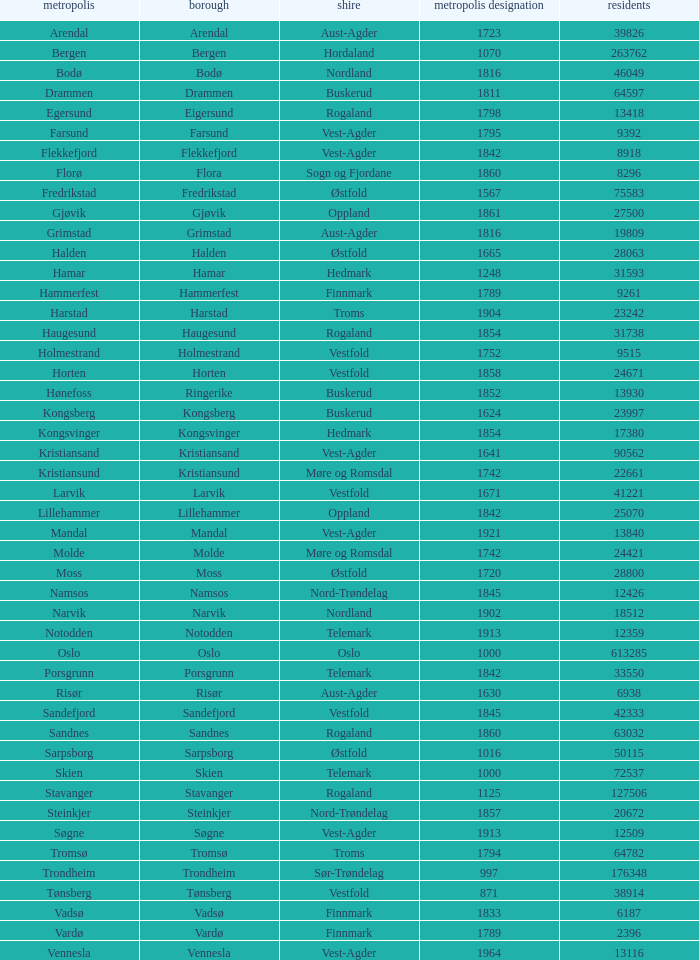What is the total population in the city/town of Arendal? 1.0. 